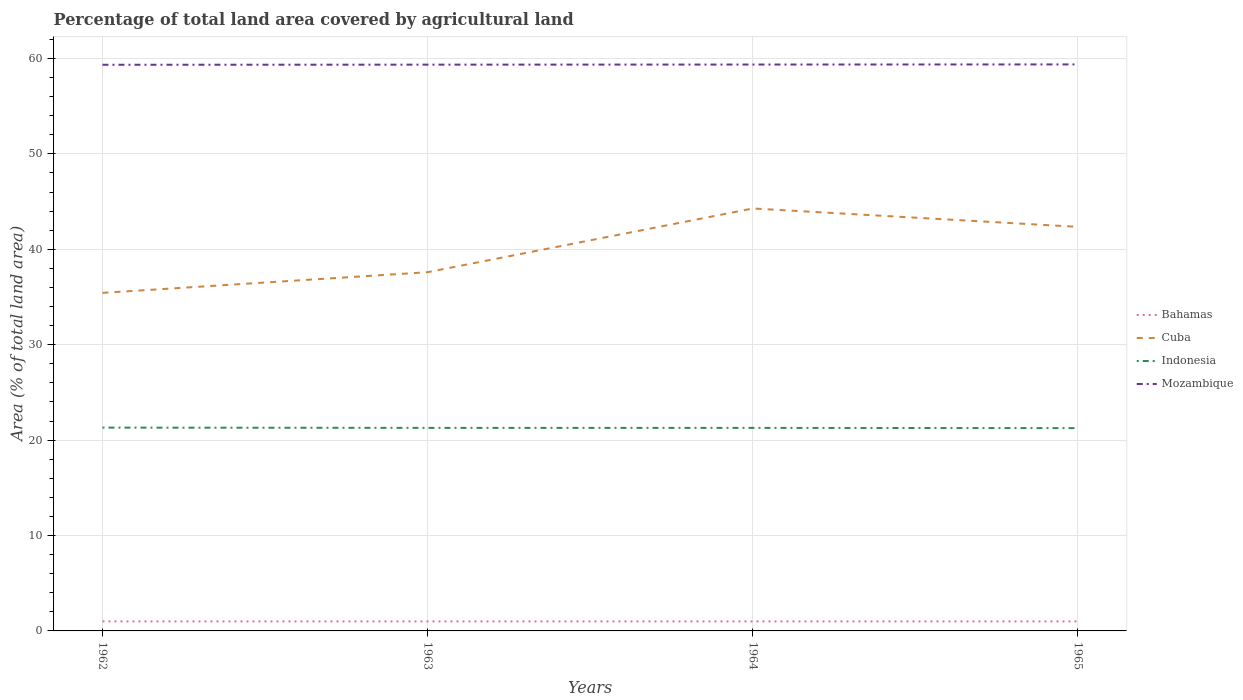Does the line corresponding to Bahamas intersect with the line corresponding to Mozambique?
Make the answer very short. No. Is the number of lines equal to the number of legend labels?
Your answer should be very brief. Yes. Across all years, what is the maximum percentage of agricultural land in Mozambique?
Offer a very short reply. 59.34. What is the total percentage of agricultural land in Cuba in the graph?
Provide a succinct answer. -6.68. What is the difference between the highest and the second highest percentage of agricultural land in Indonesia?
Your response must be concise. 0.06. Is the percentage of agricultural land in Cuba strictly greater than the percentage of agricultural land in Indonesia over the years?
Keep it short and to the point. No. How many lines are there?
Ensure brevity in your answer.  4. Does the graph contain grids?
Offer a terse response. Yes. Where does the legend appear in the graph?
Your answer should be very brief. Center right. How are the legend labels stacked?
Your response must be concise. Vertical. What is the title of the graph?
Provide a succinct answer. Percentage of total land area covered by agricultural land. Does "Tunisia" appear as one of the legend labels in the graph?
Your answer should be compact. No. What is the label or title of the X-axis?
Your answer should be compact. Years. What is the label or title of the Y-axis?
Give a very brief answer. Area (% of total land area). What is the Area (% of total land area) of Bahamas in 1962?
Offer a terse response. 1. What is the Area (% of total land area) in Cuba in 1962?
Make the answer very short. 35.43. What is the Area (% of total land area) in Indonesia in 1962?
Your answer should be compact. 21.31. What is the Area (% of total land area) in Mozambique in 1962?
Offer a terse response. 59.34. What is the Area (% of total land area) of Bahamas in 1963?
Provide a short and direct response. 1. What is the Area (% of total land area) in Cuba in 1963?
Provide a short and direct response. 37.6. What is the Area (% of total land area) of Indonesia in 1963?
Your response must be concise. 21.28. What is the Area (% of total land area) in Mozambique in 1963?
Provide a short and direct response. 59.35. What is the Area (% of total land area) of Bahamas in 1964?
Your answer should be compact. 1. What is the Area (% of total land area) of Cuba in 1964?
Your answer should be compact. 44.27. What is the Area (% of total land area) of Indonesia in 1964?
Make the answer very short. 21.28. What is the Area (% of total land area) in Mozambique in 1964?
Provide a succinct answer. 59.36. What is the Area (% of total land area) in Bahamas in 1965?
Offer a terse response. 1. What is the Area (% of total land area) of Cuba in 1965?
Offer a terse response. 42.35. What is the Area (% of total land area) of Indonesia in 1965?
Give a very brief answer. 21.25. What is the Area (% of total land area) in Mozambique in 1965?
Give a very brief answer. 59.37. Across all years, what is the maximum Area (% of total land area) of Bahamas?
Give a very brief answer. 1. Across all years, what is the maximum Area (% of total land area) of Cuba?
Your response must be concise. 44.27. Across all years, what is the maximum Area (% of total land area) of Indonesia?
Keep it short and to the point. 21.31. Across all years, what is the maximum Area (% of total land area) of Mozambique?
Your response must be concise. 59.37. Across all years, what is the minimum Area (% of total land area) of Bahamas?
Ensure brevity in your answer.  1. Across all years, what is the minimum Area (% of total land area) in Cuba?
Make the answer very short. 35.43. Across all years, what is the minimum Area (% of total land area) in Indonesia?
Your answer should be compact. 21.25. Across all years, what is the minimum Area (% of total land area) of Mozambique?
Your response must be concise. 59.34. What is the total Area (% of total land area) of Bahamas in the graph?
Your response must be concise. 4. What is the total Area (% of total land area) in Cuba in the graph?
Give a very brief answer. 159.65. What is the total Area (% of total land area) in Indonesia in the graph?
Offer a very short reply. 85.12. What is the total Area (% of total land area) of Mozambique in the graph?
Ensure brevity in your answer.  237.41. What is the difference between the Area (% of total land area) of Cuba in 1962 and that in 1963?
Your response must be concise. -2.17. What is the difference between the Area (% of total land area) of Indonesia in 1962 and that in 1963?
Your answer should be compact. 0.03. What is the difference between the Area (% of total land area) in Mozambique in 1962 and that in 1963?
Keep it short and to the point. -0.01. What is the difference between the Area (% of total land area) of Bahamas in 1962 and that in 1964?
Make the answer very short. 0. What is the difference between the Area (% of total land area) in Cuba in 1962 and that in 1964?
Make the answer very short. -8.85. What is the difference between the Area (% of total land area) of Indonesia in 1962 and that in 1964?
Make the answer very short. 0.03. What is the difference between the Area (% of total land area) of Mozambique in 1962 and that in 1964?
Your answer should be compact. -0.02. What is the difference between the Area (% of total land area) of Cuba in 1962 and that in 1965?
Your answer should be compact. -6.92. What is the difference between the Area (% of total land area) in Indonesia in 1962 and that in 1965?
Make the answer very short. 0.06. What is the difference between the Area (% of total land area) of Mozambique in 1962 and that in 1965?
Provide a short and direct response. -0.04. What is the difference between the Area (% of total land area) of Cuba in 1963 and that in 1964?
Provide a short and direct response. -6.68. What is the difference between the Area (% of total land area) of Mozambique in 1963 and that in 1964?
Your response must be concise. -0.01. What is the difference between the Area (% of total land area) in Bahamas in 1963 and that in 1965?
Give a very brief answer. 0. What is the difference between the Area (% of total land area) in Cuba in 1963 and that in 1965?
Offer a terse response. -4.75. What is the difference between the Area (% of total land area) of Indonesia in 1963 and that in 1965?
Provide a succinct answer. 0.03. What is the difference between the Area (% of total land area) in Mozambique in 1963 and that in 1965?
Your response must be concise. -0.02. What is the difference between the Area (% of total land area) in Bahamas in 1964 and that in 1965?
Make the answer very short. 0. What is the difference between the Area (% of total land area) of Cuba in 1964 and that in 1965?
Your answer should be very brief. 1.93. What is the difference between the Area (% of total land area) of Indonesia in 1964 and that in 1965?
Make the answer very short. 0.03. What is the difference between the Area (% of total land area) of Mozambique in 1964 and that in 1965?
Provide a short and direct response. -0.01. What is the difference between the Area (% of total land area) of Bahamas in 1962 and the Area (% of total land area) of Cuba in 1963?
Ensure brevity in your answer.  -36.6. What is the difference between the Area (% of total land area) of Bahamas in 1962 and the Area (% of total land area) of Indonesia in 1963?
Your answer should be compact. -20.28. What is the difference between the Area (% of total land area) in Bahamas in 1962 and the Area (% of total land area) in Mozambique in 1963?
Your response must be concise. -58.35. What is the difference between the Area (% of total land area) of Cuba in 1962 and the Area (% of total land area) of Indonesia in 1963?
Your answer should be compact. 14.15. What is the difference between the Area (% of total land area) in Cuba in 1962 and the Area (% of total land area) in Mozambique in 1963?
Provide a short and direct response. -23.92. What is the difference between the Area (% of total land area) of Indonesia in 1962 and the Area (% of total land area) of Mozambique in 1963?
Ensure brevity in your answer.  -38.04. What is the difference between the Area (% of total land area) in Bahamas in 1962 and the Area (% of total land area) in Cuba in 1964?
Provide a succinct answer. -43.27. What is the difference between the Area (% of total land area) of Bahamas in 1962 and the Area (% of total land area) of Indonesia in 1964?
Ensure brevity in your answer.  -20.28. What is the difference between the Area (% of total land area) in Bahamas in 1962 and the Area (% of total land area) in Mozambique in 1964?
Provide a short and direct response. -58.36. What is the difference between the Area (% of total land area) of Cuba in 1962 and the Area (% of total land area) of Indonesia in 1964?
Provide a succinct answer. 14.15. What is the difference between the Area (% of total land area) in Cuba in 1962 and the Area (% of total land area) in Mozambique in 1964?
Give a very brief answer. -23.93. What is the difference between the Area (% of total land area) of Indonesia in 1962 and the Area (% of total land area) of Mozambique in 1964?
Ensure brevity in your answer.  -38.05. What is the difference between the Area (% of total land area) of Bahamas in 1962 and the Area (% of total land area) of Cuba in 1965?
Provide a succinct answer. -41.35. What is the difference between the Area (% of total land area) in Bahamas in 1962 and the Area (% of total land area) in Indonesia in 1965?
Provide a short and direct response. -20.25. What is the difference between the Area (% of total land area) of Bahamas in 1962 and the Area (% of total land area) of Mozambique in 1965?
Your answer should be very brief. -58.37. What is the difference between the Area (% of total land area) in Cuba in 1962 and the Area (% of total land area) in Indonesia in 1965?
Provide a succinct answer. 14.18. What is the difference between the Area (% of total land area) in Cuba in 1962 and the Area (% of total land area) in Mozambique in 1965?
Your response must be concise. -23.94. What is the difference between the Area (% of total land area) of Indonesia in 1962 and the Area (% of total land area) of Mozambique in 1965?
Your response must be concise. -38.06. What is the difference between the Area (% of total land area) of Bahamas in 1963 and the Area (% of total land area) of Cuba in 1964?
Provide a succinct answer. -43.27. What is the difference between the Area (% of total land area) of Bahamas in 1963 and the Area (% of total land area) of Indonesia in 1964?
Your answer should be very brief. -20.28. What is the difference between the Area (% of total land area) in Bahamas in 1963 and the Area (% of total land area) in Mozambique in 1964?
Make the answer very short. -58.36. What is the difference between the Area (% of total land area) in Cuba in 1963 and the Area (% of total land area) in Indonesia in 1964?
Offer a very short reply. 16.32. What is the difference between the Area (% of total land area) of Cuba in 1963 and the Area (% of total land area) of Mozambique in 1964?
Give a very brief answer. -21.76. What is the difference between the Area (% of total land area) of Indonesia in 1963 and the Area (% of total land area) of Mozambique in 1964?
Give a very brief answer. -38.08. What is the difference between the Area (% of total land area) in Bahamas in 1963 and the Area (% of total land area) in Cuba in 1965?
Your answer should be very brief. -41.35. What is the difference between the Area (% of total land area) in Bahamas in 1963 and the Area (% of total land area) in Indonesia in 1965?
Your response must be concise. -20.25. What is the difference between the Area (% of total land area) in Bahamas in 1963 and the Area (% of total land area) in Mozambique in 1965?
Offer a very short reply. -58.37. What is the difference between the Area (% of total land area) of Cuba in 1963 and the Area (% of total land area) of Indonesia in 1965?
Your response must be concise. 16.35. What is the difference between the Area (% of total land area) of Cuba in 1963 and the Area (% of total land area) of Mozambique in 1965?
Your response must be concise. -21.77. What is the difference between the Area (% of total land area) in Indonesia in 1963 and the Area (% of total land area) in Mozambique in 1965?
Offer a very short reply. -38.09. What is the difference between the Area (% of total land area) in Bahamas in 1964 and the Area (% of total land area) in Cuba in 1965?
Make the answer very short. -41.35. What is the difference between the Area (% of total land area) in Bahamas in 1964 and the Area (% of total land area) in Indonesia in 1965?
Your response must be concise. -20.25. What is the difference between the Area (% of total land area) in Bahamas in 1964 and the Area (% of total land area) in Mozambique in 1965?
Offer a terse response. -58.37. What is the difference between the Area (% of total land area) in Cuba in 1964 and the Area (% of total land area) in Indonesia in 1965?
Offer a terse response. 23.02. What is the difference between the Area (% of total land area) of Cuba in 1964 and the Area (% of total land area) of Mozambique in 1965?
Provide a short and direct response. -15.1. What is the difference between the Area (% of total land area) in Indonesia in 1964 and the Area (% of total land area) in Mozambique in 1965?
Give a very brief answer. -38.09. What is the average Area (% of total land area) of Cuba per year?
Make the answer very short. 39.91. What is the average Area (% of total land area) in Indonesia per year?
Your answer should be very brief. 21.28. What is the average Area (% of total land area) of Mozambique per year?
Offer a terse response. 59.35. In the year 1962, what is the difference between the Area (% of total land area) of Bahamas and Area (% of total land area) of Cuba?
Make the answer very short. -34.43. In the year 1962, what is the difference between the Area (% of total land area) in Bahamas and Area (% of total land area) in Indonesia?
Provide a succinct answer. -20.31. In the year 1962, what is the difference between the Area (% of total land area) in Bahamas and Area (% of total land area) in Mozambique?
Keep it short and to the point. -58.34. In the year 1962, what is the difference between the Area (% of total land area) in Cuba and Area (% of total land area) in Indonesia?
Your response must be concise. 14.12. In the year 1962, what is the difference between the Area (% of total land area) in Cuba and Area (% of total land area) in Mozambique?
Make the answer very short. -23.91. In the year 1962, what is the difference between the Area (% of total land area) of Indonesia and Area (% of total land area) of Mozambique?
Ensure brevity in your answer.  -38.03. In the year 1963, what is the difference between the Area (% of total land area) in Bahamas and Area (% of total land area) in Cuba?
Keep it short and to the point. -36.6. In the year 1963, what is the difference between the Area (% of total land area) of Bahamas and Area (% of total land area) of Indonesia?
Your response must be concise. -20.28. In the year 1963, what is the difference between the Area (% of total land area) in Bahamas and Area (% of total land area) in Mozambique?
Keep it short and to the point. -58.35. In the year 1963, what is the difference between the Area (% of total land area) of Cuba and Area (% of total land area) of Indonesia?
Provide a short and direct response. 16.32. In the year 1963, what is the difference between the Area (% of total land area) in Cuba and Area (% of total land area) in Mozambique?
Ensure brevity in your answer.  -21.75. In the year 1963, what is the difference between the Area (% of total land area) in Indonesia and Area (% of total land area) in Mozambique?
Offer a terse response. -38.07. In the year 1964, what is the difference between the Area (% of total land area) in Bahamas and Area (% of total land area) in Cuba?
Offer a terse response. -43.27. In the year 1964, what is the difference between the Area (% of total land area) of Bahamas and Area (% of total land area) of Indonesia?
Keep it short and to the point. -20.28. In the year 1964, what is the difference between the Area (% of total land area) of Bahamas and Area (% of total land area) of Mozambique?
Keep it short and to the point. -58.36. In the year 1964, what is the difference between the Area (% of total land area) of Cuba and Area (% of total land area) of Indonesia?
Make the answer very short. 22.99. In the year 1964, what is the difference between the Area (% of total land area) in Cuba and Area (% of total land area) in Mozambique?
Keep it short and to the point. -15.08. In the year 1964, what is the difference between the Area (% of total land area) of Indonesia and Area (% of total land area) of Mozambique?
Your response must be concise. -38.08. In the year 1965, what is the difference between the Area (% of total land area) in Bahamas and Area (% of total land area) in Cuba?
Offer a terse response. -41.35. In the year 1965, what is the difference between the Area (% of total land area) in Bahamas and Area (% of total land area) in Indonesia?
Provide a short and direct response. -20.25. In the year 1965, what is the difference between the Area (% of total land area) of Bahamas and Area (% of total land area) of Mozambique?
Your response must be concise. -58.37. In the year 1965, what is the difference between the Area (% of total land area) of Cuba and Area (% of total land area) of Indonesia?
Keep it short and to the point. 21.09. In the year 1965, what is the difference between the Area (% of total land area) in Cuba and Area (% of total land area) in Mozambique?
Provide a succinct answer. -17.02. In the year 1965, what is the difference between the Area (% of total land area) of Indonesia and Area (% of total land area) of Mozambique?
Make the answer very short. -38.12. What is the ratio of the Area (% of total land area) in Cuba in 1962 to that in 1963?
Provide a short and direct response. 0.94. What is the ratio of the Area (% of total land area) in Indonesia in 1962 to that in 1963?
Provide a succinct answer. 1. What is the ratio of the Area (% of total land area) in Cuba in 1962 to that in 1964?
Offer a terse response. 0.8. What is the ratio of the Area (% of total land area) of Mozambique in 1962 to that in 1964?
Your answer should be very brief. 1. What is the ratio of the Area (% of total land area) in Cuba in 1962 to that in 1965?
Offer a very short reply. 0.84. What is the ratio of the Area (% of total land area) of Indonesia in 1962 to that in 1965?
Give a very brief answer. 1. What is the ratio of the Area (% of total land area) in Bahamas in 1963 to that in 1964?
Your answer should be compact. 1. What is the ratio of the Area (% of total land area) in Cuba in 1963 to that in 1964?
Keep it short and to the point. 0.85. What is the ratio of the Area (% of total land area) of Mozambique in 1963 to that in 1964?
Your answer should be compact. 1. What is the ratio of the Area (% of total land area) in Cuba in 1963 to that in 1965?
Keep it short and to the point. 0.89. What is the ratio of the Area (% of total land area) of Bahamas in 1964 to that in 1965?
Offer a very short reply. 1. What is the ratio of the Area (% of total land area) of Cuba in 1964 to that in 1965?
Your answer should be very brief. 1.05. What is the difference between the highest and the second highest Area (% of total land area) of Bahamas?
Provide a short and direct response. 0. What is the difference between the highest and the second highest Area (% of total land area) of Cuba?
Offer a terse response. 1.93. What is the difference between the highest and the second highest Area (% of total land area) in Indonesia?
Provide a short and direct response. 0.03. What is the difference between the highest and the second highest Area (% of total land area) of Mozambique?
Your answer should be compact. 0.01. What is the difference between the highest and the lowest Area (% of total land area) in Bahamas?
Offer a terse response. 0. What is the difference between the highest and the lowest Area (% of total land area) of Cuba?
Ensure brevity in your answer.  8.85. What is the difference between the highest and the lowest Area (% of total land area) of Indonesia?
Make the answer very short. 0.06. What is the difference between the highest and the lowest Area (% of total land area) of Mozambique?
Make the answer very short. 0.04. 